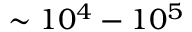<formula> <loc_0><loc_0><loc_500><loc_500>\sim 1 0 ^ { 4 } - 1 0 ^ { 5 }</formula> 